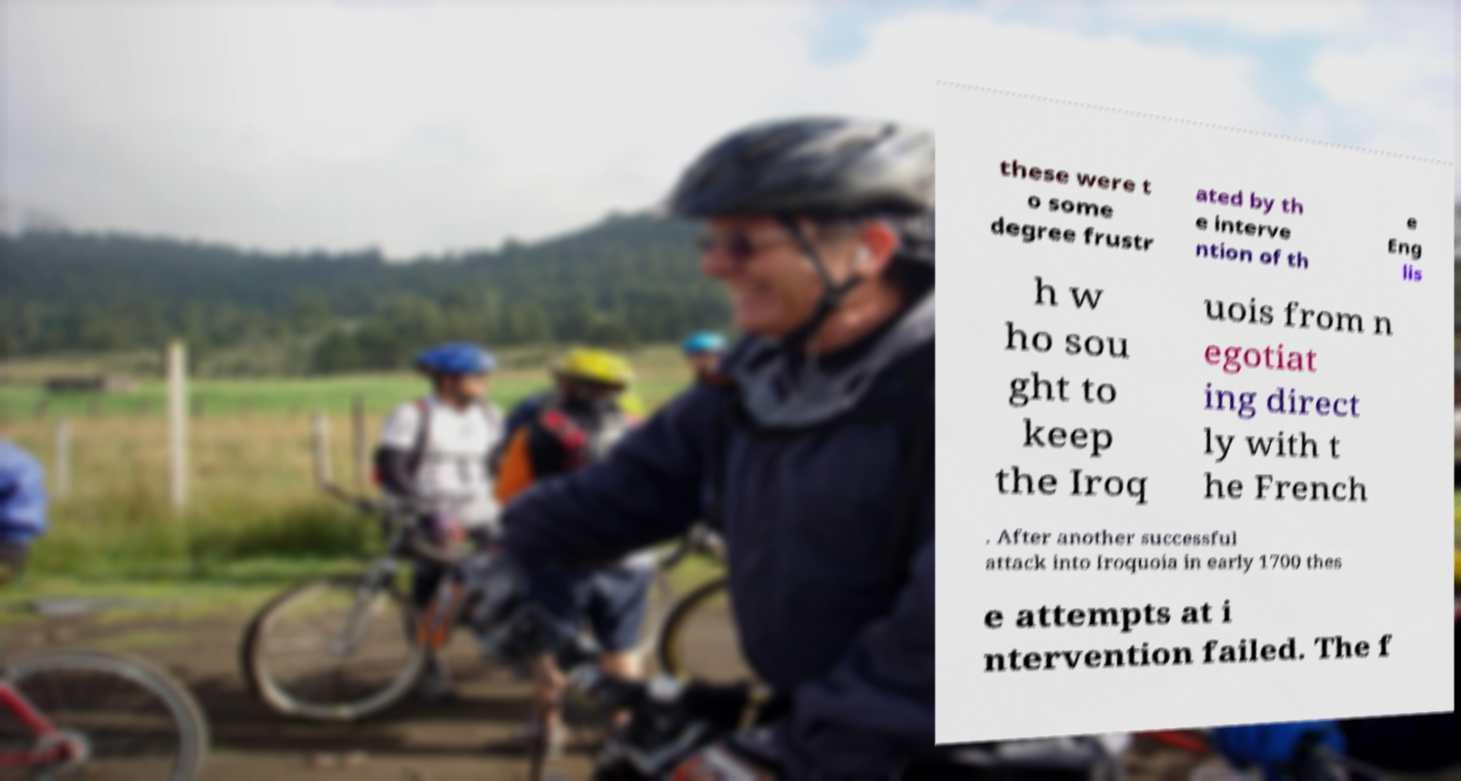Could you assist in decoding the text presented in this image and type it out clearly? these were t o some degree frustr ated by th e interve ntion of th e Eng lis h w ho sou ght to keep the Iroq uois from n egotiat ing direct ly with t he French . After another successful attack into Iroquoia in early 1700 thes e attempts at i ntervention failed. The f 